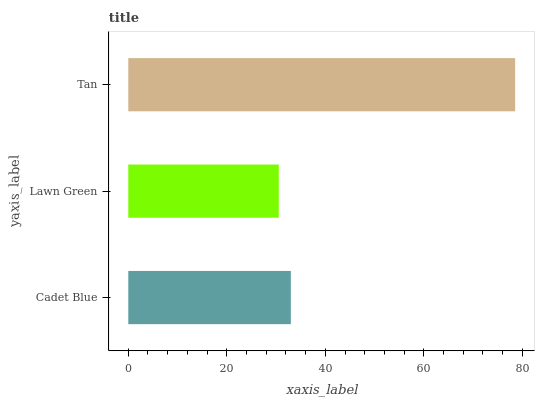Is Lawn Green the minimum?
Answer yes or no. Yes. Is Tan the maximum?
Answer yes or no. Yes. Is Tan the minimum?
Answer yes or no. No. Is Lawn Green the maximum?
Answer yes or no. No. Is Tan greater than Lawn Green?
Answer yes or no. Yes. Is Lawn Green less than Tan?
Answer yes or no. Yes. Is Lawn Green greater than Tan?
Answer yes or no. No. Is Tan less than Lawn Green?
Answer yes or no. No. Is Cadet Blue the high median?
Answer yes or no. Yes. Is Cadet Blue the low median?
Answer yes or no. Yes. Is Tan the high median?
Answer yes or no. No. Is Tan the low median?
Answer yes or no. No. 